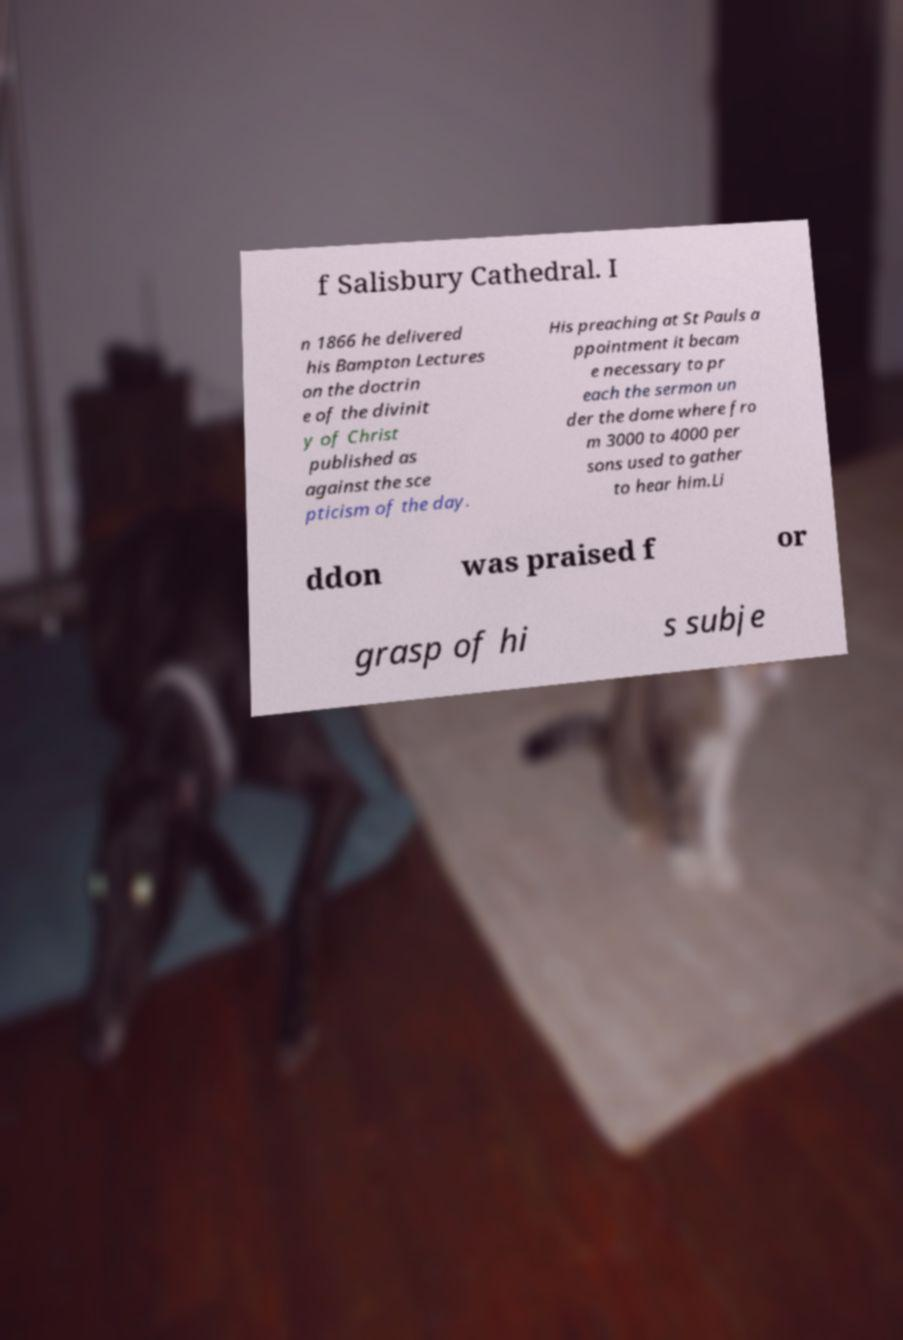For documentation purposes, I need the text within this image transcribed. Could you provide that? f Salisbury Cathedral. I n 1866 he delivered his Bampton Lectures on the doctrin e of the divinit y of Christ published as against the sce pticism of the day. His preaching at St Pauls a ppointment it becam e necessary to pr each the sermon un der the dome where fro m 3000 to 4000 per sons used to gather to hear him.Li ddon was praised f or grasp of hi s subje 